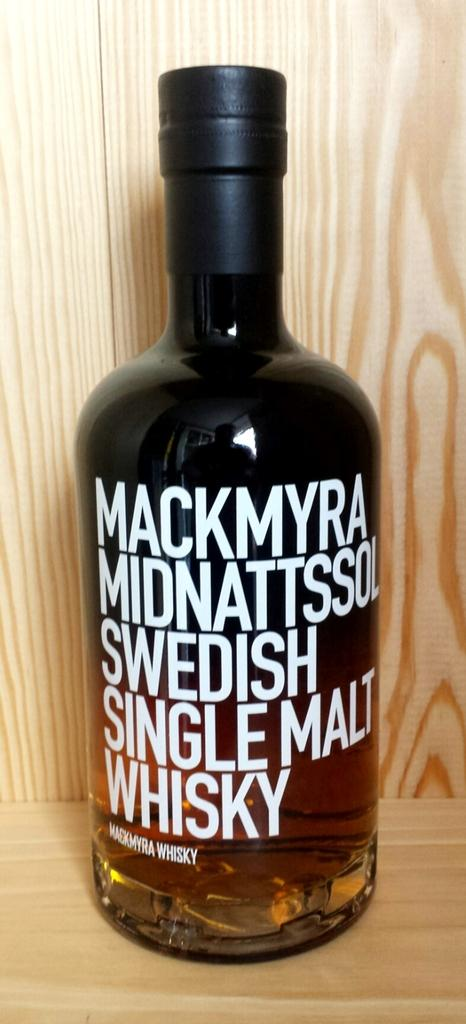<image>
Write a terse but informative summary of the picture. A bottle of Mackmyra Midnattssol Swedish Single Malt Whisky on a piece of wood. 